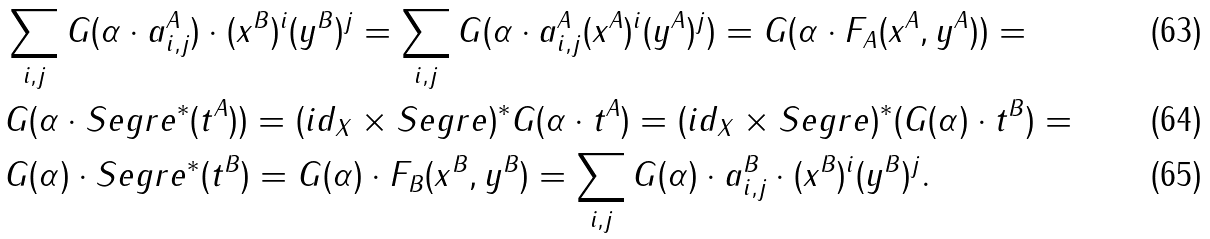Convert formula to latex. <formula><loc_0><loc_0><loc_500><loc_500>& \sum _ { i , j } G ( \alpha \cdot a _ { i , j } ^ { A } ) \cdot ( x ^ { B } ) ^ { i } ( y ^ { B } ) ^ { j } = \sum _ { i , j } G ( \alpha \cdot a _ { i , j } ^ { A } ( x ^ { A } ) ^ { i } ( y ^ { A } ) ^ { j } ) = G ( \alpha \cdot F _ { A } ( x ^ { A } , y ^ { A } ) ) = \\ & G ( \alpha \cdot S e g r e ^ { * } ( t ^ { A } ) ) = ( i d _ { X } \times S e g r e ) ^ { * } G ( \alpha \cdot t ^ { A } ) = ( i d _ { X } \times S e g r e ) ^ { * } ( G ( \alpha ) \cdot t ^ { B } ) = \\ & G ( \alpha ) \cdot S e g r e ^ { * } ( t ^ { B } ) = G ( \alpha ) \cdot F _ { B } ( x ^ { B } , y ^ { B } ) = \sum _ { i , j } G ( \alpha ) \cdot a _ { i , j } ^ { B } \cdot ( x ^ { B } ) ^ { i } ( y ^ { B } ) ^ { j } .</formula> 